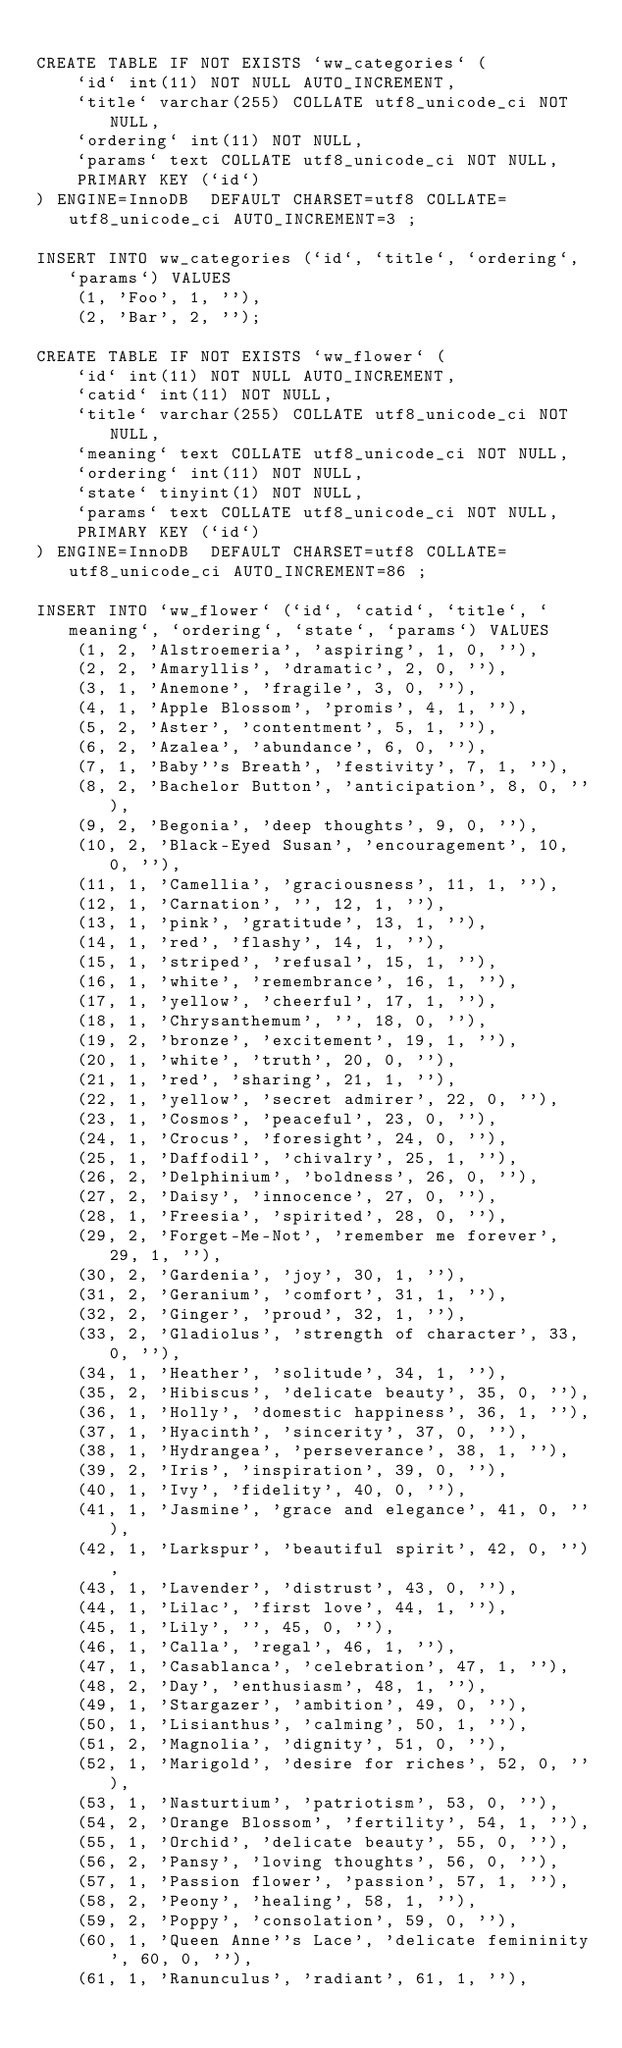Convert code to text. <code><loc_0><loc_0><loc_500><loc_500><_SQL_>
CREATE TABLE IF NOT EXISTS `ww_categories` (
	`id` int(11) NOT NULL AUTO_INCREMENT,
	`title` varchar(255) COLLATE utf8_unicode_ci NOT NULL,
	`ordering` int(11) NOT NULL,
	`params` text COLLATE utf8_unicode_ci NOT NULL,
	PRIMARY KEY (`id`)
) ENGINE=InnoDB  DEFAULT CHARSET=utf8 COLLATE=utf8_unicode_ci AUTO_INCREMENT=3 ;

INSERT INTO ww_categories (`id`, `title`, `ordering`, `params`) VALUES
	(1, 'Foo', 1, ''),
	(2, 'Bar', 2, '');

CREATE TABLE IF NOT EXISTS `ww_flower` (
	`id` int(11) NOT NULL AUTO_INCREMENT,
	`catid` int(11) NOT NULL,
	`title` varchar(255) COLLATE utf8_unicode_ci NOT NULL,
	`meaning` text COLLATE utf8_unicode_ci NOT NULL,
	`ordering` int(11) NOT NULL,
	`state` tinyint(1) NOT NULL,
	`params` text COLLATE utf8_unicode_ci NOT NULL,
	PRIMARY KEY (`id`)
) ENGINE=InnoDB  DEFAULT CHARSET=utf8 COLLATE=utf8_unicode_ci AUTO_INCREMENT=86 ;

INSERT INTO `ww_flower` (`id`, `catid`, `title`, `meaning`, `ordering`, `state`, `params`) VALUES
	(1, 2, 'Alstroemeria', 'aspiring', 1, 0, ''),
	(2, 2, 'Amaryllis', 'dramatic', 2, 0, ''),
	(3, 1, 'Anemone', 'fragile', 3, 0, ''),
	(4, 1, 'Apple Blossom', 'promis', 4, 1, ''),
	(5, 2, 'Aster', 'contentment', 5, 1, ''),
	(6, 2, 'Azalea', 'abundance', 6, 0, ''),
	(7, 1, 'Baby''s Breath', 'festivity', 7, 1, ''),
	(8, 2, 'Bachelor Button', 'anticipation', 8, 0, ''),
	(9, 2, 'Begonia', 'deep thoughts', 9, 0, ''),
	(10, 2, 'Black-Eyed Susan', 'encouragement', 10, 0, ''),
	(11, 1, 'Camellia', 'graciousness', 11, 1, ''),
	(12, 1, 'Carnation', '', 12, 1, ''),
	(13, 1, 'pink', 'gratitude', 13, 1, ''),
	(14, 1, 'red', 'flashy', 14, 1, ''),
	(15, 1, 'striped', 'refusal', 15, 1, ''),
	(16, 1, 'white', 'remembrance', 16, 1, ''),
	(17, 1, 'yellow', 'cheerful', 17, 1, ''),
	(18, 1, 'Chrysanthemum', '', 18, 0, ''),
	(19, 2, 'bronze', 'excitement', 19, 1, ''),
	(20, 1, 'white', 'truth', 20, 0, ''),
	(21, 1, 'red', 'sharing', 21, 1, ''),
	(22, 1, 'yellow', 'secret admirer', 22, 0, ''),
	(23, 1, 'Cosmos', 'peaceful', 23, 0, ''),
	(24, 1, 'Crocus', 'foresight', 24, 0, ''),
	(25, 1, 'Daffodil', 'chivalry', 25, 1, ''),
	(26, 2, 'Delphinium', 'boldness', 26, 0, ''),
	(27, 2, 'Daisy', 'innocence', 27, 0, ''),
	(28, 1, 'Freesia', 'spirited', 28, 0, ''),
	(29, 2, 'Forget-Me-Not', 'remember me forever', 29, 1, ''),
	(30, 2, 'Gardenia', 'joy', 30, 1, ''),
	(31, 2, 'Geranium', 'comfort', 31, 1, ''),
	(32, 2, 'Ginger', 'proud', 32, 1, ''),
	(33, 2, 'Gladiolus', 'strength of character', 33, 0, ''),
	(34, 1, 'Heather', 'solitude', 34, 1, ''),
	(35, 2, 'Hibiscus', 'delicate beauty', 35, 0, ''),
	(36, 1, 'Holly', 'domestic happiness', 36, 1, ''),
	(37, 1, 'Hyacinth', 'sincerity', 37, 0, ''),
	(38, 1, 'Hydrangea', 'perseverance', 38, 1, ''),
	(39, 2, 'Iris', 'inspiration', 39, 0, ''),
	(40, 1, 'Ivy', 'fidelity', 40, 0, ''),
	(41, 1, 'Jasmine', 'grace and elegance', 41, 0, ''),
	(42, 1, 'Larkspur', 'beautiful spirit', 42, 0, ''),
	(43, 1, 'Lavender', 'distrust', 43, 0, ''),
	(44, 1, 'Lilac', 'first love', 44, 1, ''),
	(45, 1, 'Lily', '', 45, 0, ''),
	(46, 1, 'Calla', 'regal', 46, 1, ''),
	(47, 1, 'Casablanca', 'celebration', 47, 1, ''),
	(48, 2, 'Day', 'enthusiasm', 48, 1, ''),
	(49, 1, 'Stargazer', 'ambition', 49, 0, ''),
	(50, 1, 'Lisianthus', 'calming', 50, 1, ''),
	(51, 2, 'Magnolia', 'dignity', 51, 0, ''),
	(52, 1, 'Marigold', 'desire for riches', 52, 0, ''),
	(53, 1, 'Nasturtium', 'patriotism', 53, 0, ''),
	(54, 2, 'Orange Blossom', 'fertility', 54, 1, ''),
	(55, 1, 'Orchid', 'delicate beauty', 55, 0, ''),
	(56, 2, 'Pansy', 'loving thoughts', 56, 0, ''),
	(57, 1, 'Passion flower', 'passion', 57, 1, ''),
	(58, 2, 'Peony', 'healing', 58, 1, ''),
	(59, 2, 'Poppy', 'consolation', 59, 0, ''),
	(60, 1, 'Queen Anne''s Lace', 'delicate femininity', 60, 0, ''),
	(61, 1, 'Ranunculus', 'radiant', 61, 1, ''),</code> 